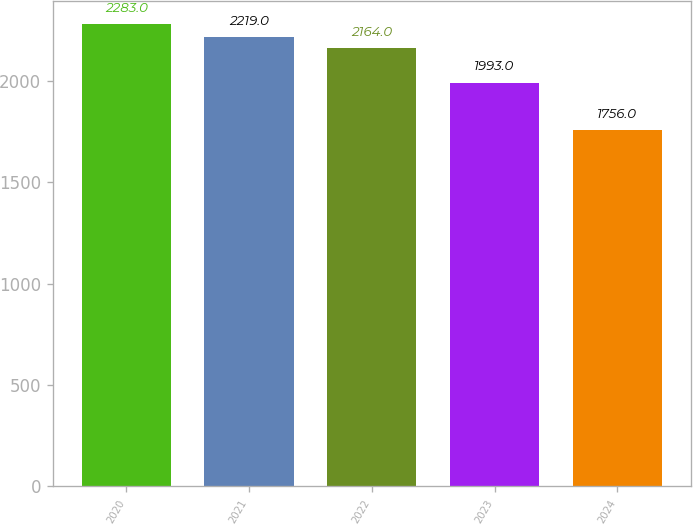Convert chart. <chart><loc_0><loc_0><loc_500><loc_500><bar_chart><fcel>2020<fcel>2021<fcel>2022<fcel>2023<fcel>2024<nl><fcel>2283<fcel>2219<fcel>2164<fcel>1993<fcel>1756<nl></chart> 